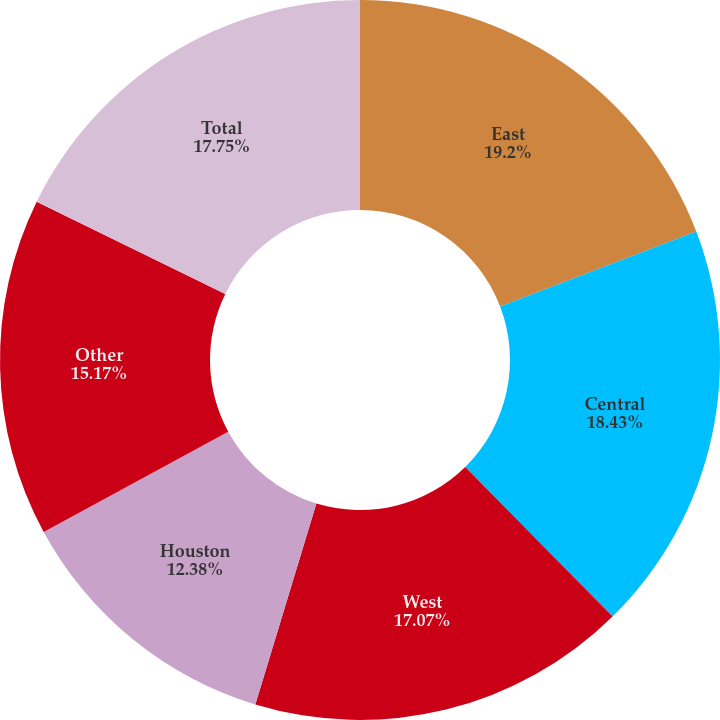Convert chart. <chart><loc_0><loc_0><loc_500><loc_500><pie_chart><fcel>East<fcel>Central<fcel>West<fcel>Houston<fcel>Other<fcel>Total<nl><fcel>19.19%<fcel>18.43%<fcel>17.07%<fcel>12.38%<fcel>15.17%<fcel>17.75%<nl></chart> 